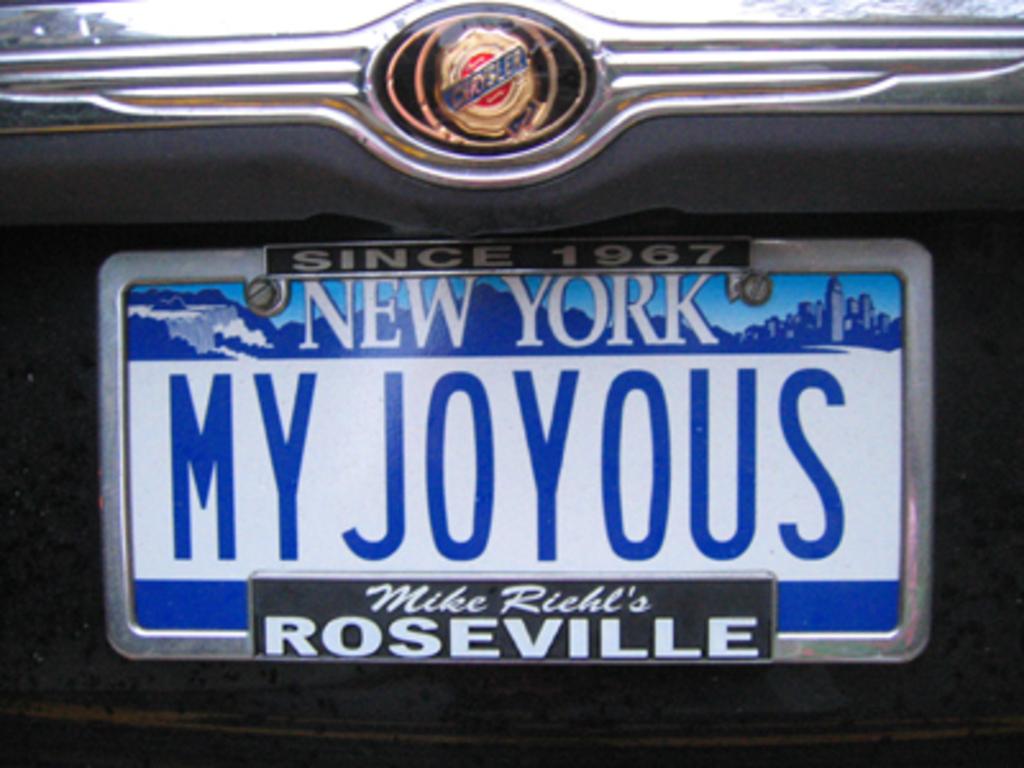What does the license plate say?
Give a very brief answer. My joyous. 